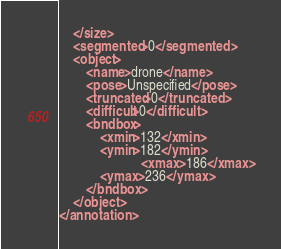Convert code to text. <code><loc_0><loc_0><loc_500><loc_500><_XML_>	</size>
	<segmented>0</segmented>
	<object>
		<name>drone</name>
		<pose>Unspecified</pose>
		<truncated>0</truncated>
		<difficult>0</difficult>
		<bndbox>
			<xmin>132</xmin>
			<ymin>182</ymin>
                        <xmax>186</xmax>
			<ymax>236</ymax>
		</bndbox>
	</object>
</annotation>
</code> 